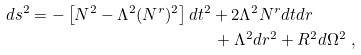Convert formula to latex. <formula><loc_0><loc_0><loc_500><loc_500>d s ^ { 2 } = - \left [ N ^ { 2 } - \Lambda ^ { 2 } ( N ^ { r } ) ^ { 2 } \right ] d t ^ { 2 } & + 2 \Lambda ^ { 2 } N ^ { r } d t d r \\ & \, + \Lambda ^ { 2 } d r ^ { 2 } + R ^ { 2 } d \Omega ^ { 2 } \ ,</formula> 